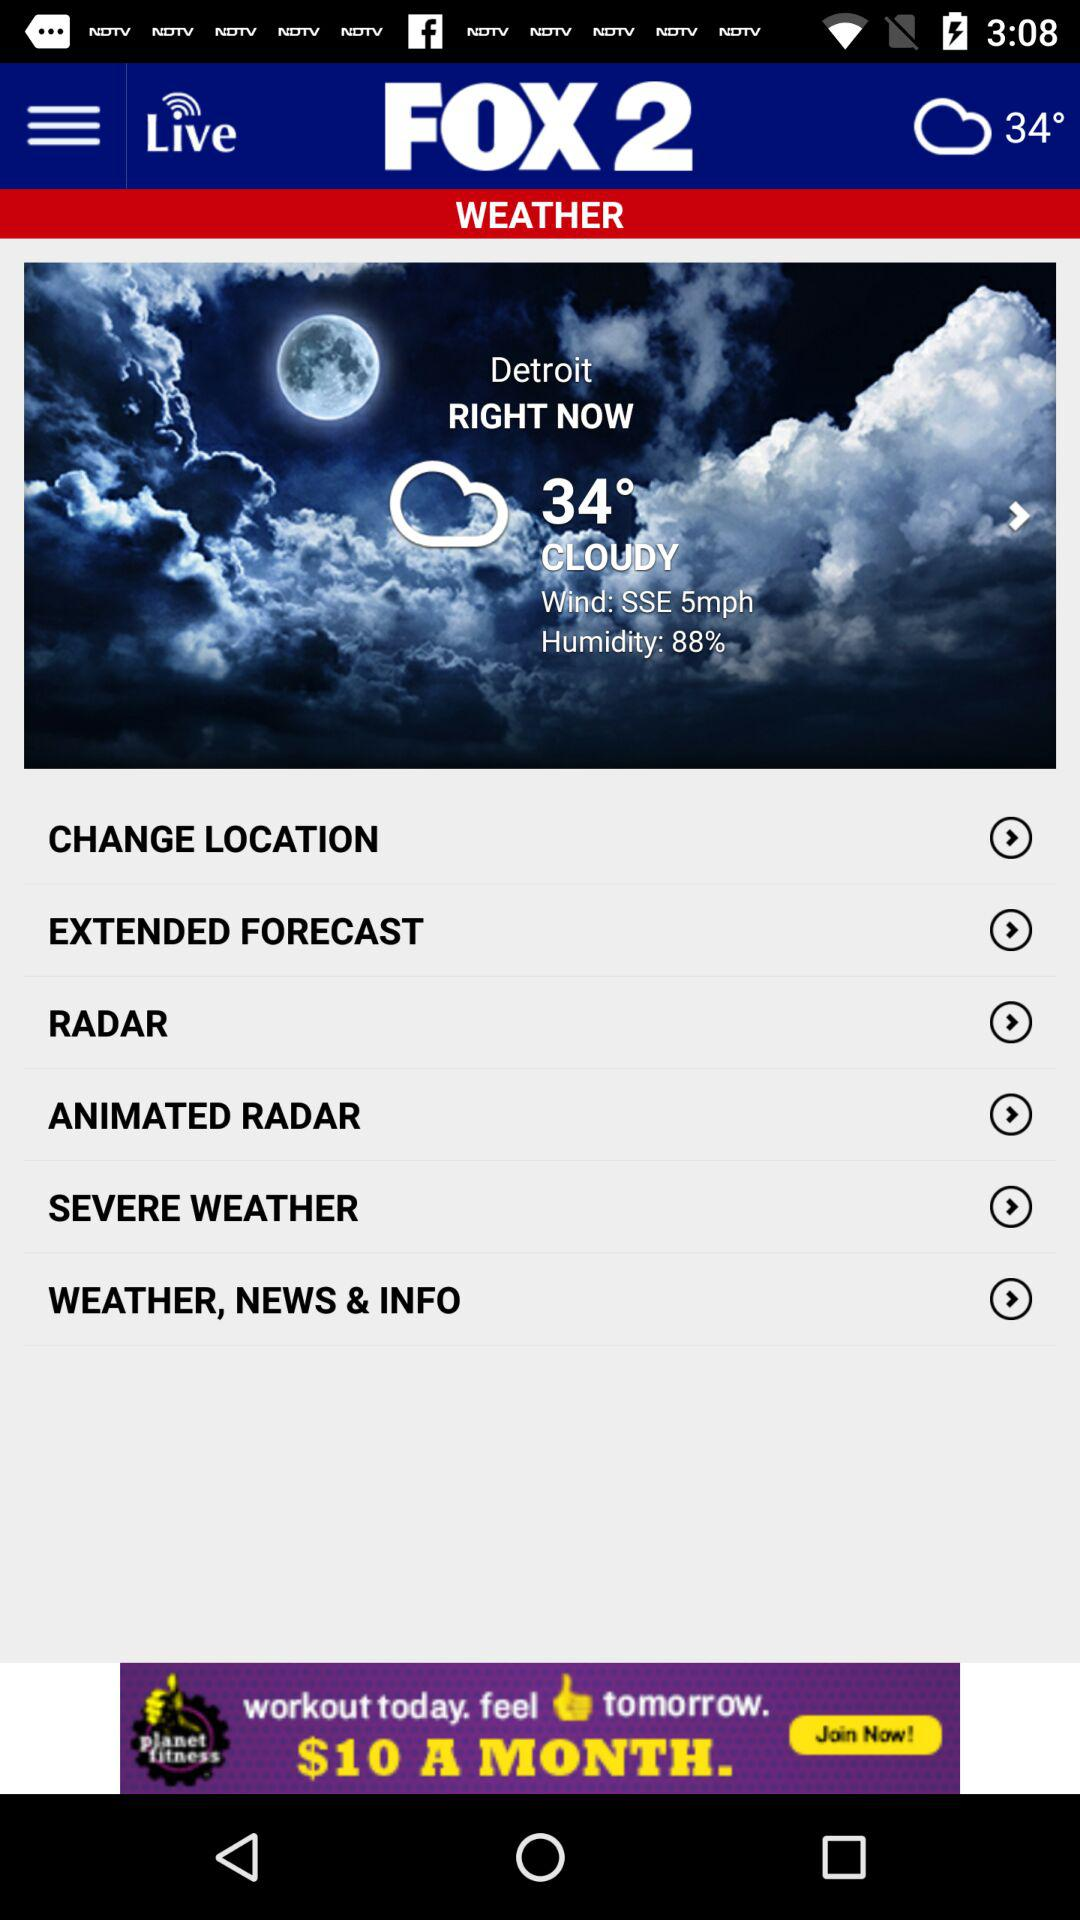How many degrees Fahrenheit is the temperature in Detroit? According to the screenshot provided, the current temperature in Detroit is 34 degrees Fahrenheit, with cloudy conditions. The wind is coming from the south-southeast at 5 mph and the humidity level is quite high at 88%. 